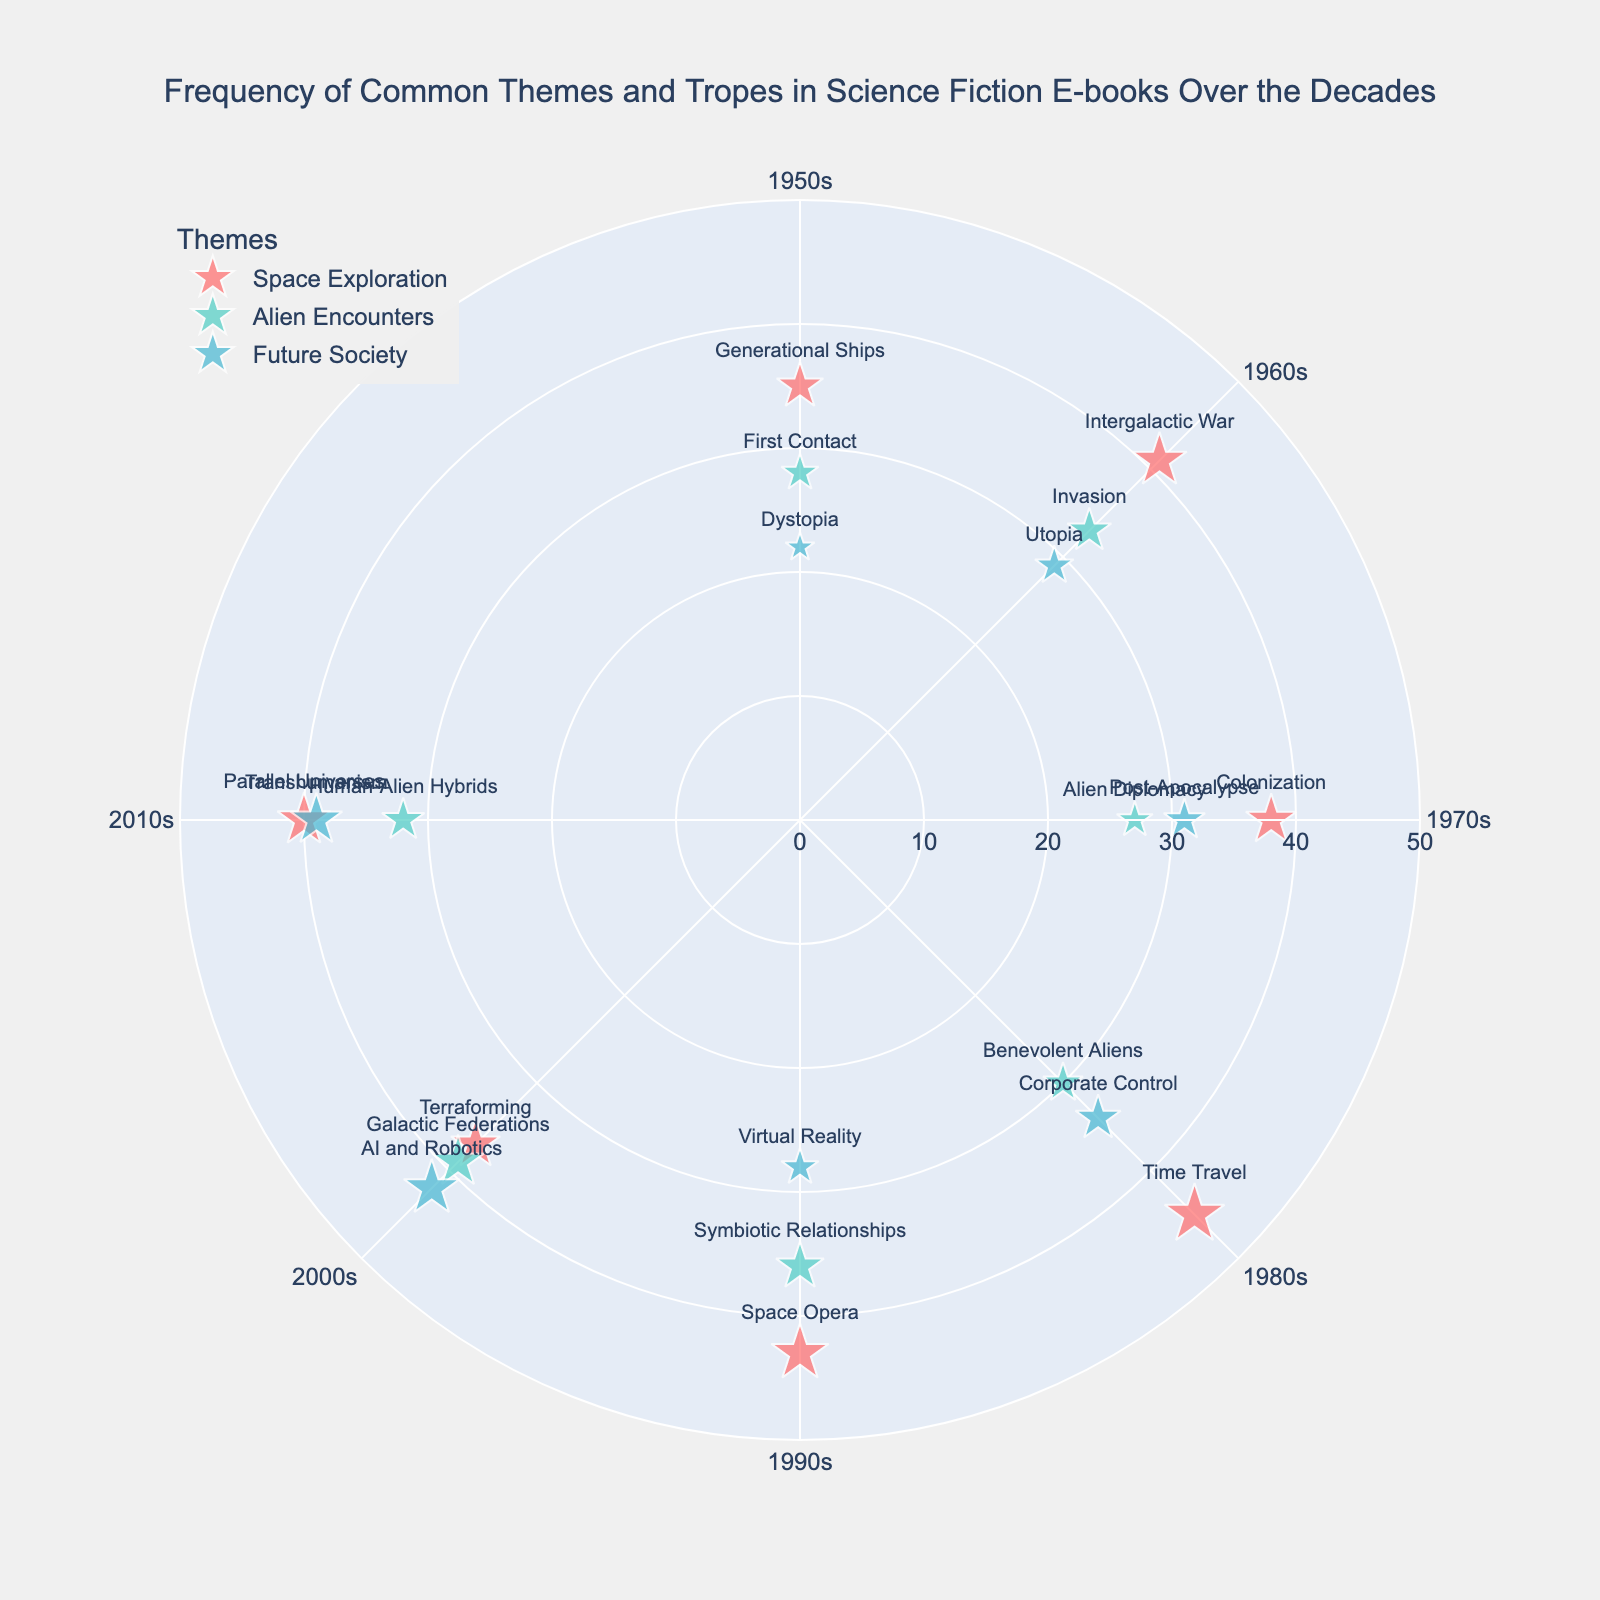What decade shows the highest frequency for Space Exploration tropes? Look at the markers for Space Exploration in the figure. Space Exploration tropes corresponding to the 1980s (45) have the largest marker size indicating the highest frequency.
Answer: 1980s How many tropes are associated with the Alien Encounters theme in the overall plot? Count the number of markers associated with the color representing Alien Encounters (17). There are markers in every decade from 1950s to 2010s.
Answer: 7 What is the average frequency of the Future Society tropes in the figure? Sum the frequencies for each decade for Future Society (22, 29, 31, 34, 28, 42, 39), which equals 225. Then divide by the number of decades, which is 7. The average is 225 / 7.
Answer: 32.14 Which trope in the 2000s has the highest frequency and under which theme does it fall? Look at the 225-degree markers for the largest size in the 2000s. The largest marker frequency is 42 for AI and Robotics under Future Society.
Answer: AI and Robotics, Future Society Compare the frequency of Alien Encounters tropes between the 1980s and the 2010s. Which decade has a higher frequency? Compare the size of markers under Alien Encounters for the 135 and 270-degree markers. The 1980s has a frequency of 30, and the 2010s has a frequency of 32.
Answer: 2010s How does the frequency of First Contact in the 1950s compare to Intergalactic War in the 1960s? Look at the marker sizes for First Contact in the 0-degree and Intergalactic War in the 45-degree. Their frequencies are 28 and 41 respectively.
Answer: Intergalactic War in the 1960s is higher What is the total number of tropes represented in the 1970s for all themes combined? Count the number of different markers at the 90-degree angle. There are three markers for the 1970s.
Answer: 3 Which decade sees the highest overall frequency for tropes related to Space Exploration? Identify the highest frequency Space Exploration marker by checking frequencies and angles. The highest is Time Travel in the 1980s with 45.
Answer: 1980s What is the trend of frequencies for the Future Society tropes from the 1950s to 2010s? Examine the marker sizes for Future Society from 0 to 270-degree angles. The frequencies mostly increase from 22 to 39.
Answer: Increasing How many themes are represented in the figure? Count the number of unique themes mentioned in the figure’s legend. There are Space Exploration, Alien Encounters, and Future Society.
Answer: 3 